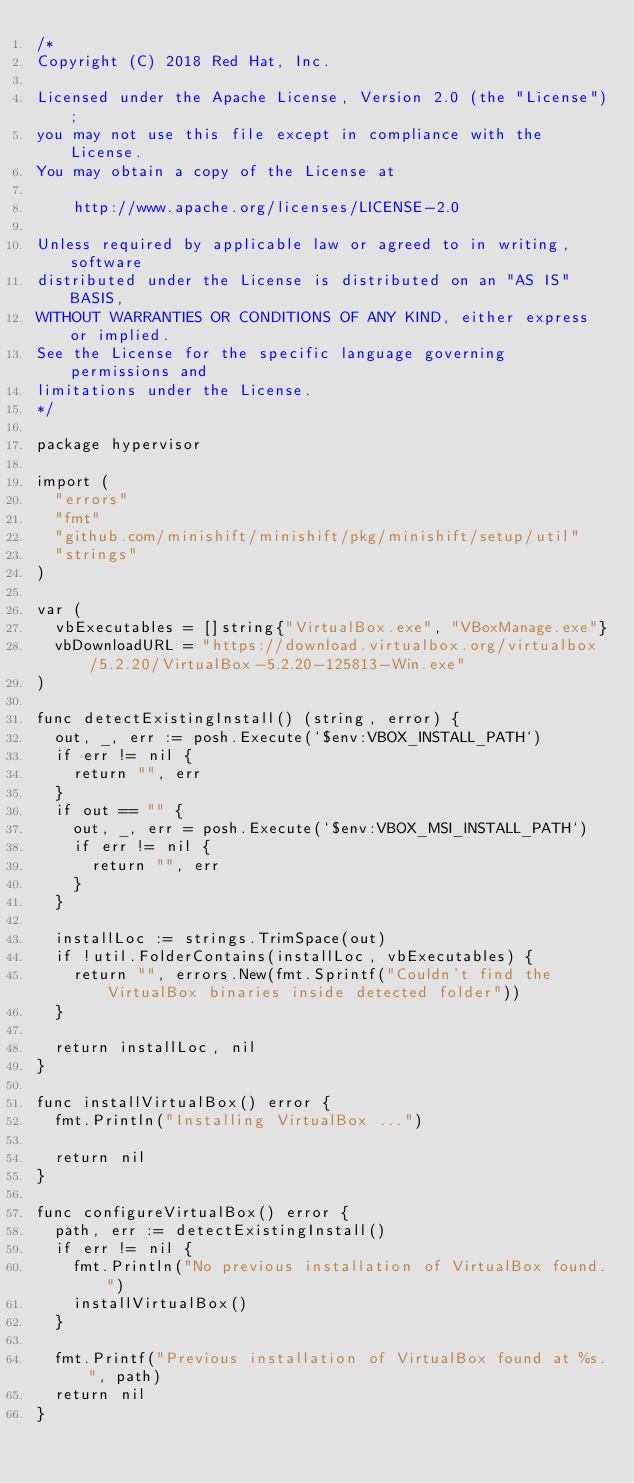Convert code to text. <code><loc_0><loc_0><loc_500><loc_500><_Go_>/*
Copyright (C) 2018 Red Hat, Inc.

Licensed under the Apache License, Version 2.0 (the "License");
you may not use this file except in compliance with the License.
You may obtain a copy of the License at

    http://www.apache.org/licenses/LICENSE-2.0

Unless required by applicable law or agreed to in writing, software
distributed under the License is distributed on an "AS IS" BASIS,
WITHOUT WARRANTIES OR CONDITIONS OF ANY KIND, either express or implied.
See the License for the specific language governing permissions and
limitations under the License.
*/

package hypervisor

import (
	"errors"
	"fmt"
	"github.com/minishift/minishift/pkg/minishift/setup/util"
	"strings"
)

var (
	vbExecutables = []string{"VirtualBox.exe", "VBoxManage.exe"}
	vbDownloadURL = "https://download.virtualbox.org/virtualbox/5.2.20/VirtualBox-5.2.20-125813-Win.exe"
)

func detectExistingInstall() (string, error) {
	out, _, err := posh.Execute(`$env:VBOX_INSTALL_PATH`)
	if err != nil {
		return "", err
	}
	if out == "" {
		out, _, err = posh.Execute(`$env:VBOX_MSI_INSTALL_PATH`)
		if err != nil {
			return "", err
		}
	}

	installLoc := strings.TrimSpace(out)
	if !util.FolderContains(installLoc, vbExecutables) {
		return "", errors.New(fmt.Sprintf("Couldn't find the VirtualBox binaries inside detected folder"))
	}

	return installLoc, nil
}

func installVirtualBox() error {
	fmt.Println("Installing VirtualBox ...")

	return nil
}

func configureVirtualBox() error {
	path, err := detectExistingInstall()
	if err != nil {
		fmt.Println("No previous installation of VirtualBox found.")
		installVirtualBox()
	}

	fmt.Printf("Previous installation of VirtualBox found at %s.", path)
	return nil
}
</code> 